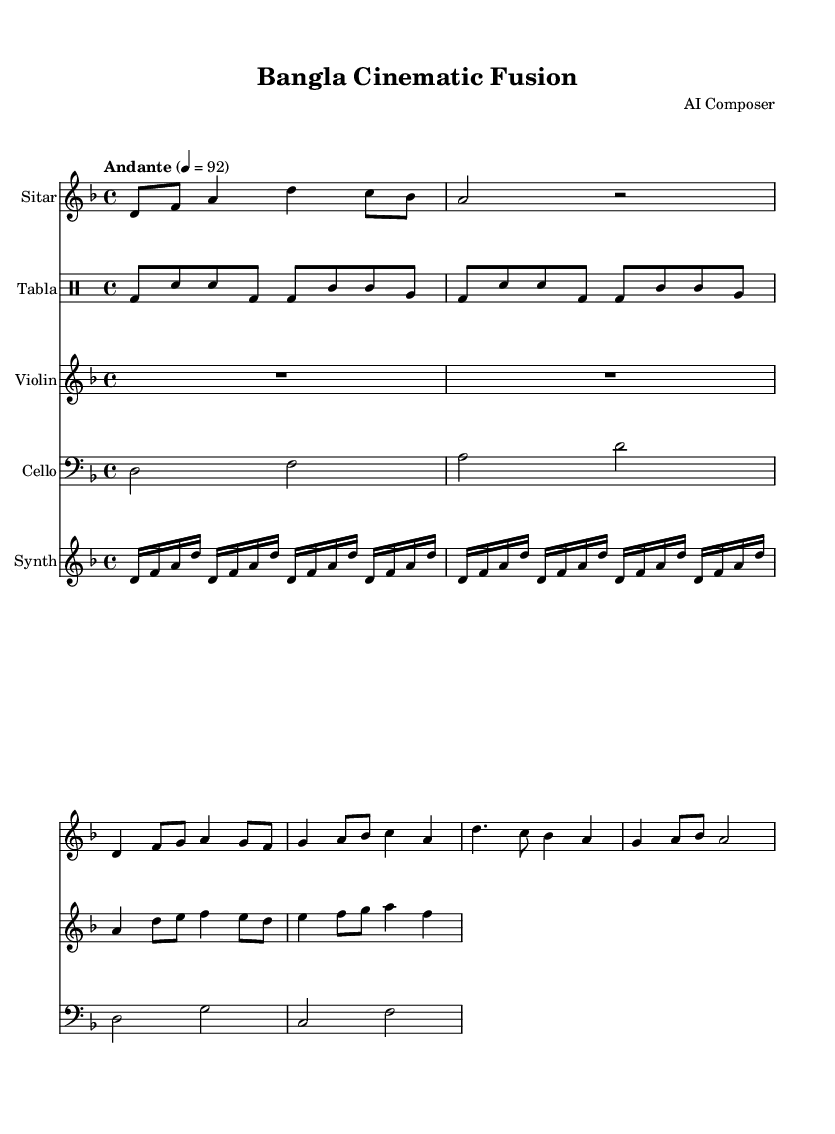What is the key signature of this music? The key signature indicates D minor, which has one flat (B flat). This can be identified at the beginning of the staff where the key signature is placed.
Answer: D minor What is the time signature of the piece? The time signature is 4/4, which is shown at the beginning of the score. The top number indicates four beats per measure, and the bottom number indicates that a quarter note gets one beat.
Answer: 4/4 What is the tempo marking for this piece? The tempo marking is "Andante" with a metronome marking of 92. This means the piece should be played at a moderately slow pace. This is found at the start of the score following the time signature.
Answer: Andante 4 = 92 Which instrument has the highest pitch? The instrument with the highest pitch is the Sitar, as its notes are typically placed higher on the staff compared to the others. When comparing the Sitar, Violin, Cello, and Synthesizer, the Sitar plays in a higher octave range.
Answer: Sitar How many measures are in the Sitar part? The Sitar part consists of 5 measures. This can be counted by identifying the number of vertical lines that separate the notes into groups on the staff.
Answer: 5 What are the rhythmic values commonly used in the Tabla part? The rhythmic values used in the Tabla part include eighth notes and quarter notes. This can be analyzed by counting the note heads and their groupings in the drum staff.
Answer: Eighth notes and quarter notes What is the dynamic level indicated for the Violin? The dynamic level indicated for the Violin is not explicitly noted, but it generally follows the common practice for film scores, suggesting a moderate dynamic. Analyzing the context and orchestration, it likely implies a softer approach contrasted with the other instruments.
Answer: Moderate 